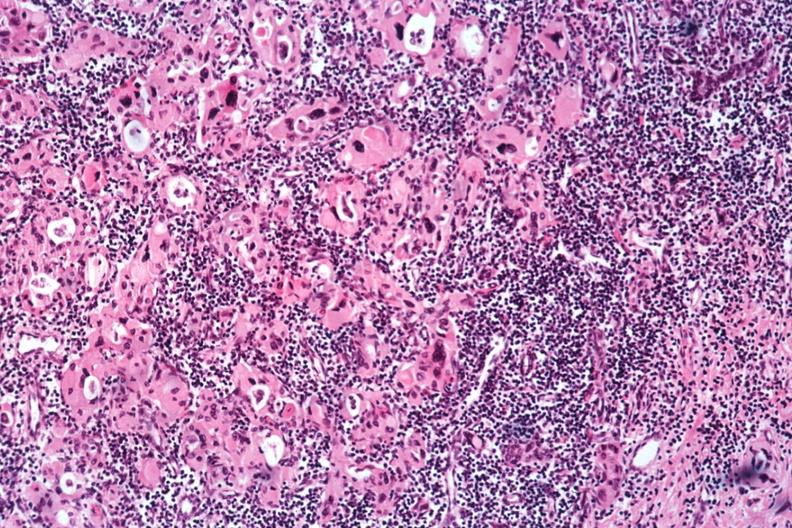what does this image show?
Answer the question using a single word or phrase. Med bizarre hurthle type cells with lymphocytic infiltrate no recognizable thyroid tissue 